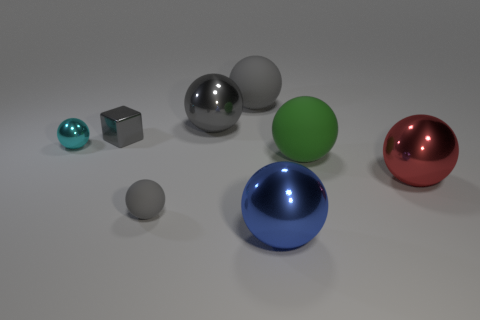What is the big blue object made of?
Give a very brief answer. Metal. What material is the large ball to the right of the big matte thing that is on the right side of the gray matte ball behind the tiny cyan ball made of?
Provide a succinct answer. Metal. Are there any other things that have the same material as the big red object?
Provide a succinct answer. Yes. Is the size of the cube the same as the rubber ball that is on the right side of the big blue metallic object?
Your answer should be compact. No. What number of things are either balls in front of the tiny gray cube or gray metallic things that are in front of the big gray shiny object?
Keep it short and to the point. 6. The ball that is behind the large gray metal object is what color?
Your answer should be very brief. Gray. Are there any red things behind the big matte sphere on the left side of the blue shiny thing?
Your answer should be very brief. No. Is the number of small metallic things less than the number of matte things?
Offer a very short reply. Yes. The small ball that is right of the small shiny thing that is left of the small gray metal cube is made of what material?
Provide a short and direct response. Rubber. Is the size of the red ball the same as the blue metallic thing?
Keep it short and to the point. Yes. 